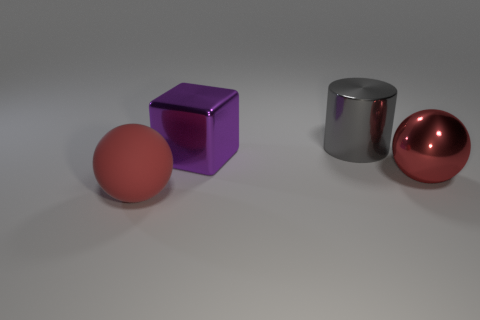How do the materials of the objects seem to differ? The objects in the image look like they're made of different materials. The sphere has a matte finish suggesting a rubbery texture, the cube has a reflective surface hinting at a metallic or plastic composition, and the cylinder seems to have a glossy, possibly metallic finish. 